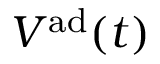Convert formula to latex. <formula><loc_0><loc_0><loc_500><loc_500>V ^ { a d } ( t )</formula> 